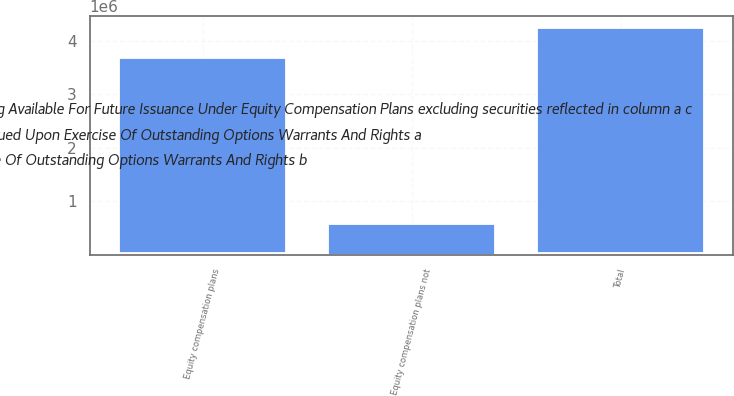Convert chart to OTSL. <chart><loc_0><loc_0><loc_500><loc_500><stacked_bar_chart><ecel><fcel>Equity compensation plans<fcel>Equity compensation plans not<fcel>Total<nl><fcel>WeightedAverage Exercise Price Of Outstanding Options Warrants And Rights b<fcel>3.65073e+06<fcel>567331<fcel>4.21806e+06<nl><fcel>Number Of Securities Remaining Available For Future Issuance Under Equity Compensation Plans excluding securities reflected in column a c<fcel>16.85<fcel>6.94<fcel>15.52<nl><fcel>Number Of Securities To Be Issued Upon Exercise Of Outstanding Options Warrants And Rights a<fcel>32014<fcel>0<fcel>32014<nl></chart> 